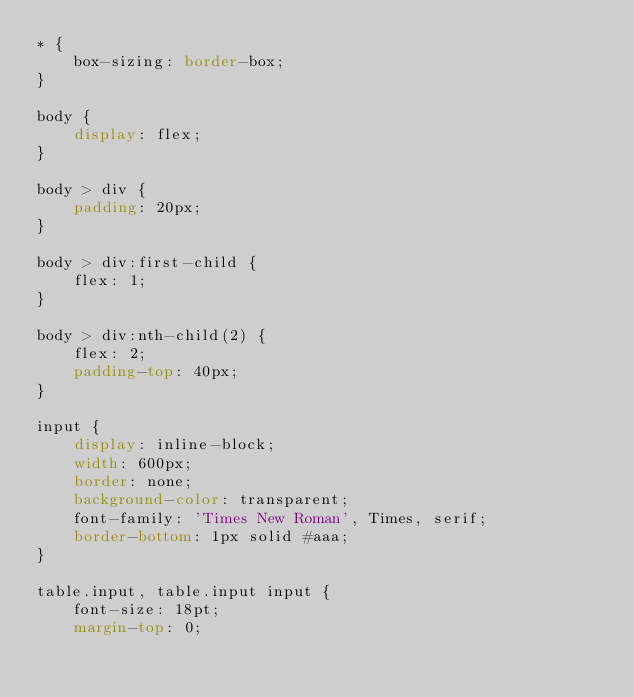Convert code to text. <code><loc_0><loc_0><loc_500><loc_500><_CSS_>* {
    box-sizing: border-box;
}

body {
    display: flex;
}

body > div {
    padding: 20px;
}

body > div:first-child {
    flex: 1;
}

body > div:nth-child(2) {
    flex: 2;
    padding-top: 40px;
}

input {
    display: inline-block;
    width: 600px;
    border: none;
    background-color: transparent;
    font-family: 'Times New Roman', Times, serif;
    border-bottom: 1px solid #aaa;
}

table.input, table.input input {
    font-size: 18pt;
    margin-top: 0;</code> 